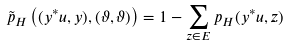Convert formula to latex. <formula><loc_0><loc_0><loc_500><loc_500>\tilde { p } _ { H } \left ( ( y ^ { * } u , y ) , ( \vartheta , \vartheta ) \right ) = 1 - \sum _ { z \in E } p _ { H } ( y ^ { * } u , z )</formula> 